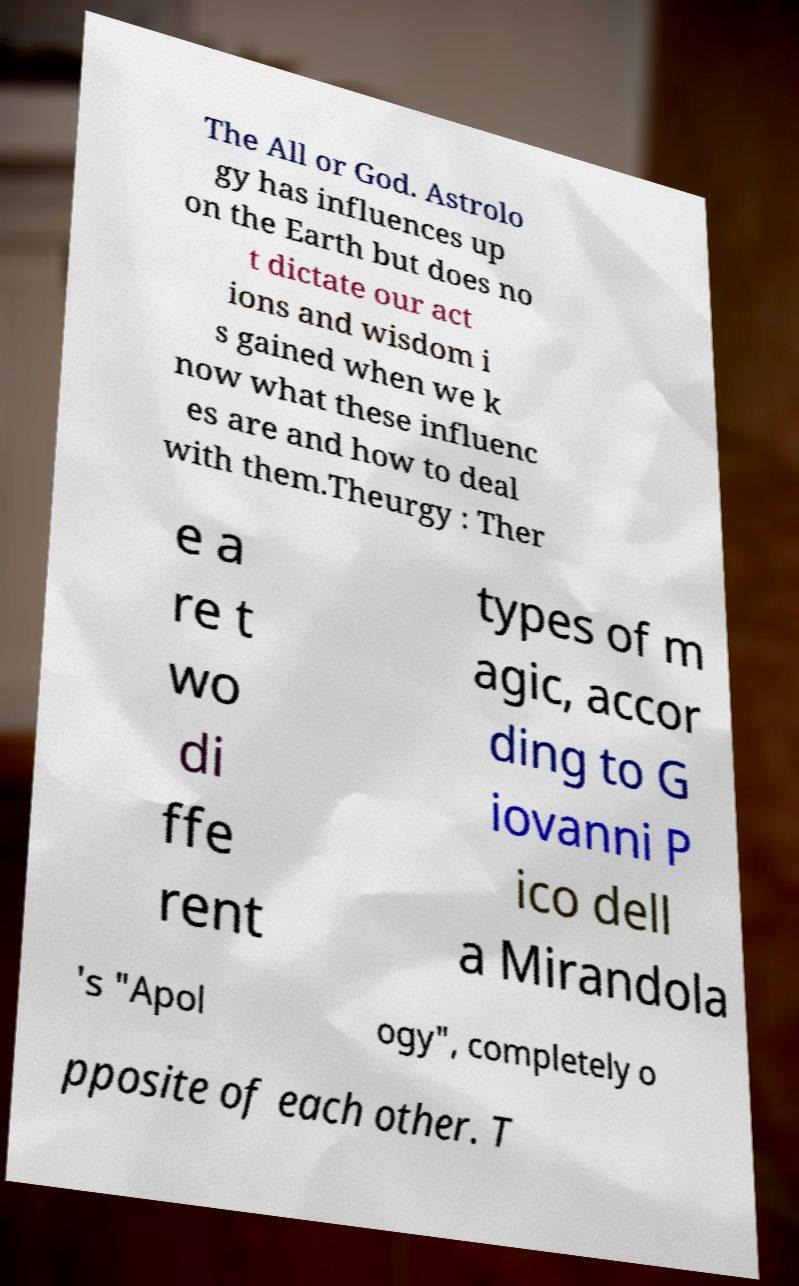There's text embedded in this image that I need extracted. Can you transcribe it verbatim? The All or God. Astrolo gy has influences up on the Earth but does no t dictate our act ions and wisdom i s gained when we k now what these influenc es are and how to deal with them.Theurgy : Ther e a re t wo di ffe rent types of m agic, accor ding to G iovanni P ico dell a Mirandola 's "Apol ogy", completely o pposite of each other. T 